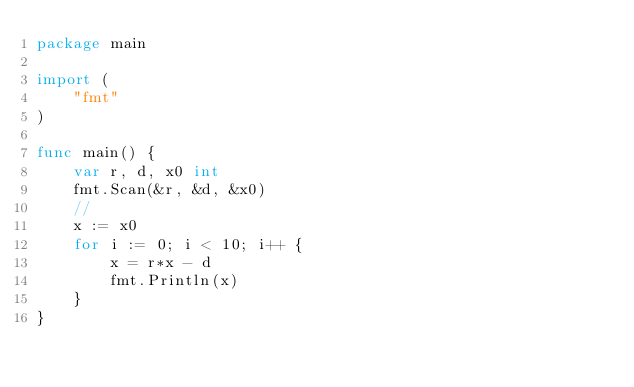<code> <loc_0><loc_0><loc_500><loc_500><_Go_>package main

import (
	"fmt"
)

func main() {
	var r, d, x0 int
	fmt.Scan(&r, &d, &x0)
	//
	x := x0
	for i := 0; i < 10; i++ {
		x = r*x - d
		fmt.Println(x)
	}
}
</code> 